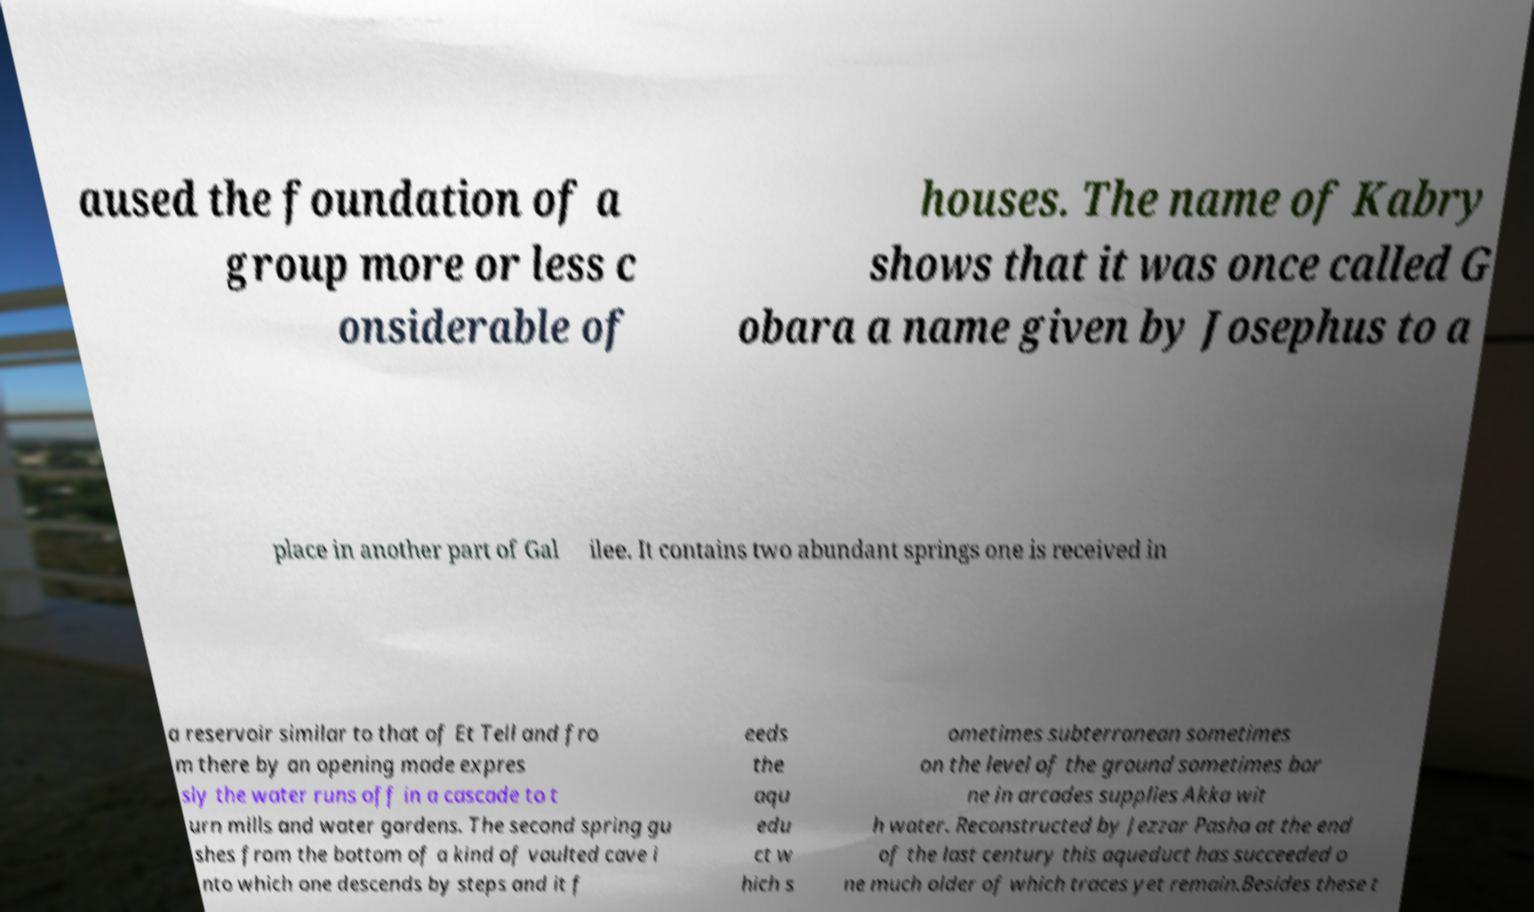Please read and relay the text visible in this image. What does it say? aused the foundation of a group more or less c onsiderable of houses. The name of Kabry shows that it was once called G obara a name given by Josephus to a place in another part of Gal ilee. It contains two abundant springs one is received in a reservoir similar to that of Et Tell and fro m there by an opening made expres sly the water runs off in a cascade to t urn mills and water gardens. The second spring gu shes from the bottom of a kind of vaulted cave i nto which one descends by steps and it f eeds the aqu edu ct w hich s ometimes subterranean sometimes on the level of the ground sometimes bor ne in arcades supplies Akka wit h water. Reconstructed by Jezzar Pasha at the end of the last century this aqueduct has succeeded o ne much older of which traces yet remain.Besides these t 